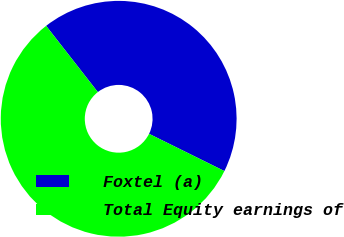<chart> <loc_0><loc_0><loc_500><loc_500><pie_chart><fcel>Foxtel (a)<fcel>Total Equity earnings of<nl><fcel>42.86%<fcel>57.14%<nl></chart> 